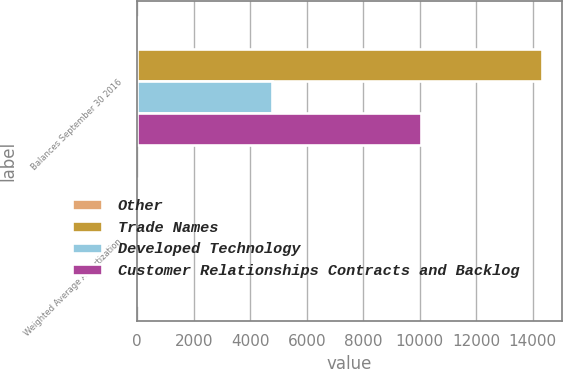Convert chart. <chart><loc_0><loc_0><loc_500><loc_500><stacked_bar_chart><ecel><fcel>Balances September 30 2016<fcel>Weighted Average Amortization<nl><fcel>Other<fcel>25<fcel>8.4<nl><fcel>Trade Names<fcel>14311<fcel>9.3<nl><fcel>Developed Technology<fcel>4786<fcel>5<nl><fcel>Customer Relationships Contracts and Backlog<fcel>10027<fcel>25<nl></chart> 